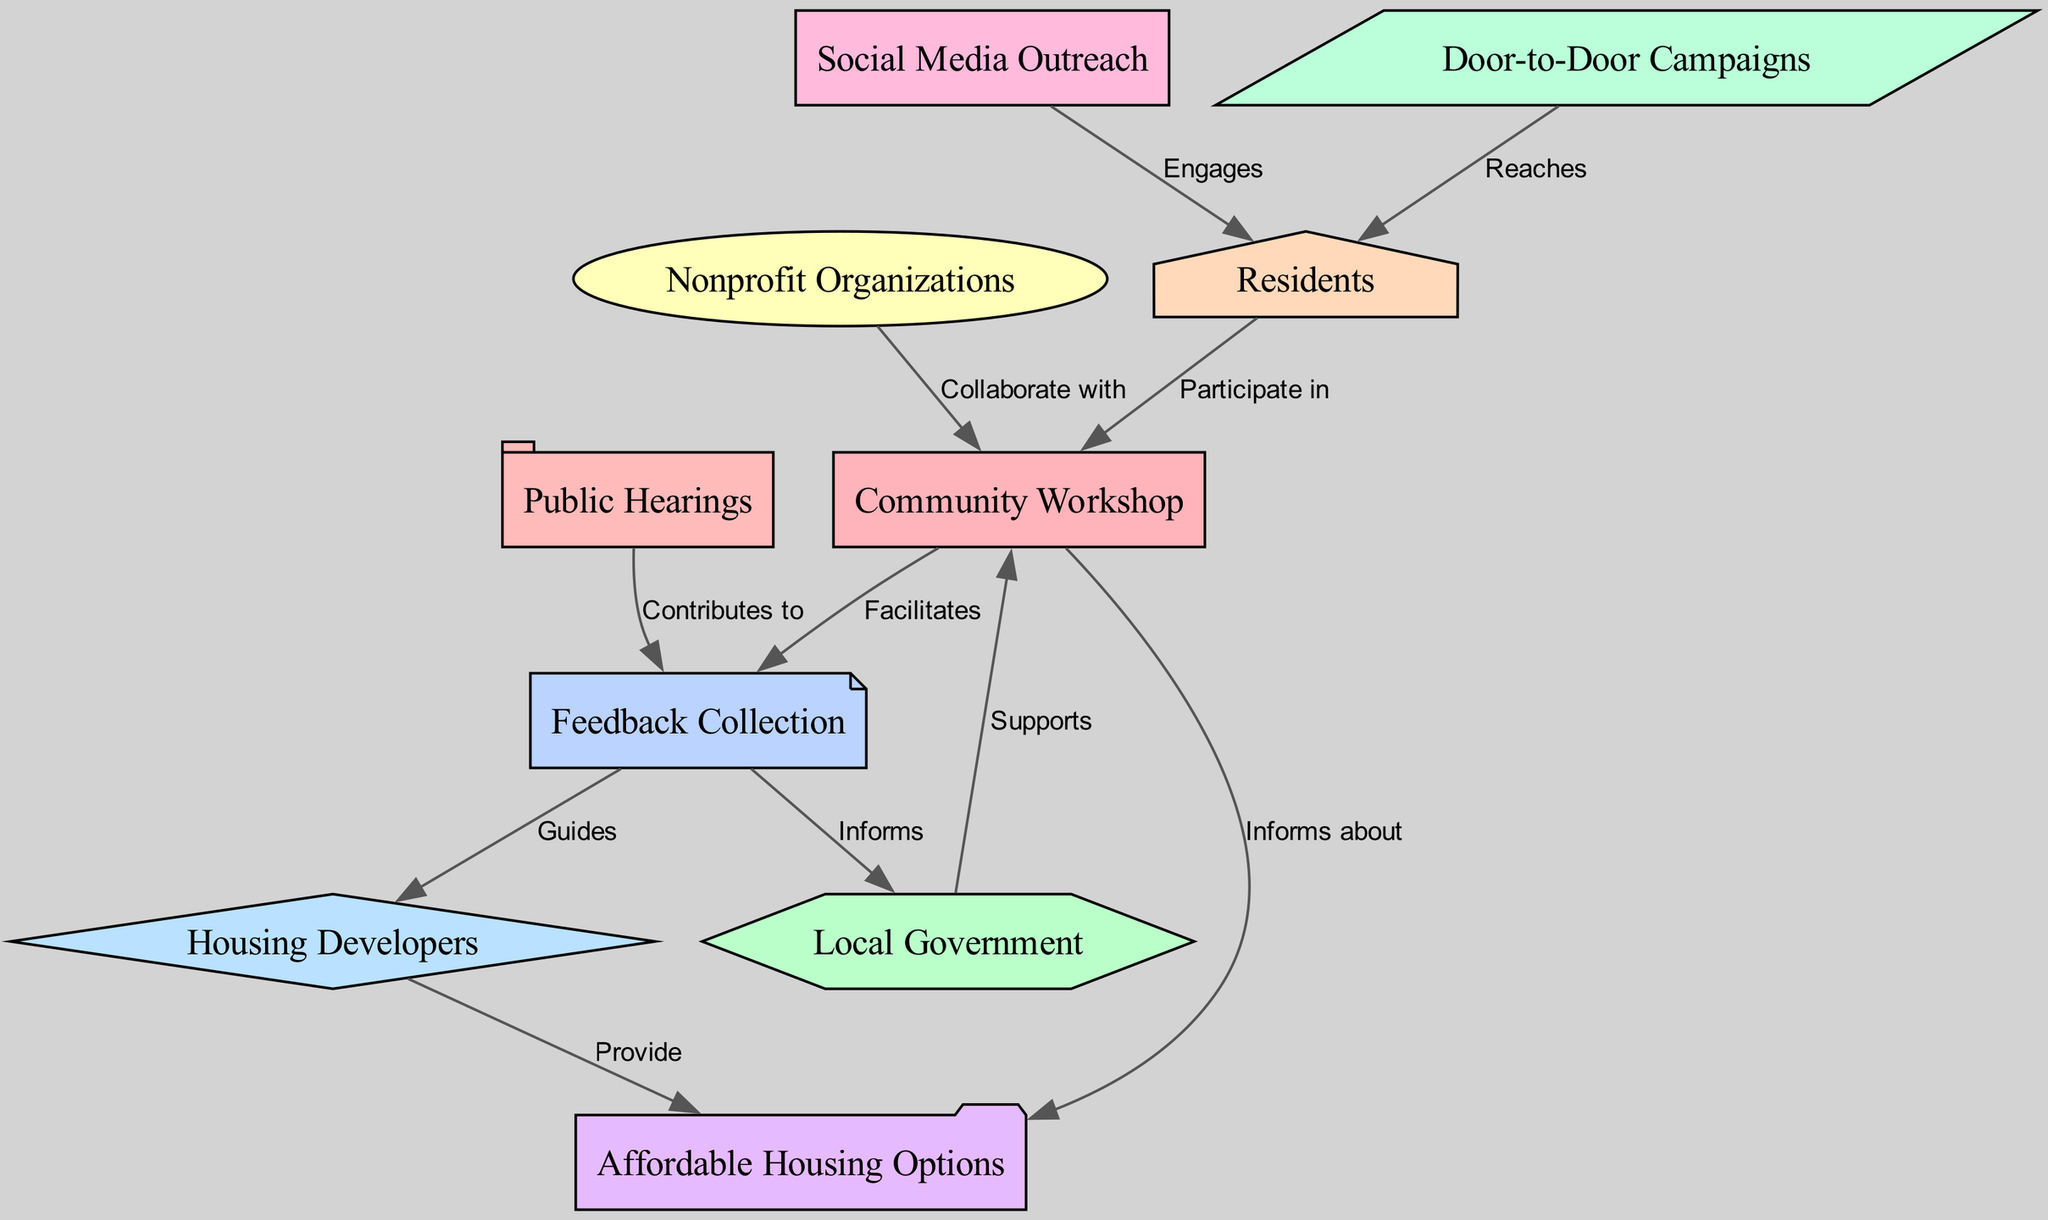What is the total number of nodes in the diagram? To find the total number of nodes, count each individual element listed in the nodes section. There are ten items listed, each representing a different entity or concept related to community engagement in affordable housing initiatives.
Answer: Ten What relationship exists between Community Workshop and Affordable Housing Options? The relationship indicated between Community Workshop and Affordable Housing Options is labeled "Informs about," showing that the workshop provides information regarding affordable housing options to the community.
Answer: Informs about How many edges are connected to Feedback Collection? By examining the edges section, we see Feedback Collection connects to three different entities: Community Workshop (facilitates), Local Government (informs), and Housing Developers (guides). Thus, it has three connections.
Answer: Three Which entity collaborates with Nonprofit Organizations? From the diagram, it can be seen that Nonprofit Organizations collaborate with Community Workshop, as indicated by the edge connecting these two nodes.
Answer: Community Workshop What type of outreach engages Residents? The diagram mentions two forms of outreach that engage Residents: Social Media Outreach and Door-to-Door Campaigns. Both are distinct but relevant methods for engaging the resident community.
Answer: Social Media Outreach and Door-to-Door Campaigns What is the relationship between Public Hearings and Feedback Collection? The relationship between Public Hearings and Feedback Collection is described as "Contributes to," meaning that Public Hearings provide input or feedback that enhances the information gathered in the Feedback Collection process.
Answer: Contributes to Which stakeholders inform the Local Government? According to the edges in the diagram, Feedback Collection is the connection that informs Local Government of the community's needs and opinions, making it a crucial channel of information.
Answer: Feedback Collection How does Feedback Collection guide Housing Developers? The diagram shows that Feedback Collection guides Housing Developers by providing insights or direction based on resident feedback and community input, helping them to better align their housing projects with community needs.
Answer: Guides What is the fundamental role of Residents in the Community Workshop? The role of Residents is shown in the diagram as "Participate in," meaning they are actively involved in the community workshops, contributing their voices and perspectives to the discussions about affordable housing.
Answer: Participate in 